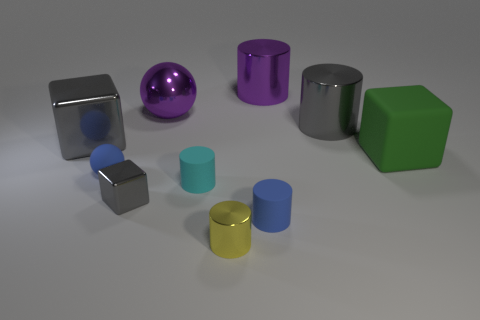Subtract all large rubber blocks. How many blocks are left? 2 Subtract 1 cubes. How many cubes are left? 2 Subtract all blocks. How many objects are left? 7 Subtract all red cylinders. Subtract all cyan spheres. How many cylinders are left? 5 Subtract all red cubes. How many brown spheres are left? 0 Subtract all big yellow rubber spheres. Subtract all matte spheres. How many objects are left? 9 Add 8 large matte cubes. How many large matte cubes are left? 9 Add 3 large shiny cubes. How many large shiny cubes exist? 4 Subtract all purple cylinders. How many cylinders are left? 4 Subtract 0 cyan balls. How many objects are left? 10 